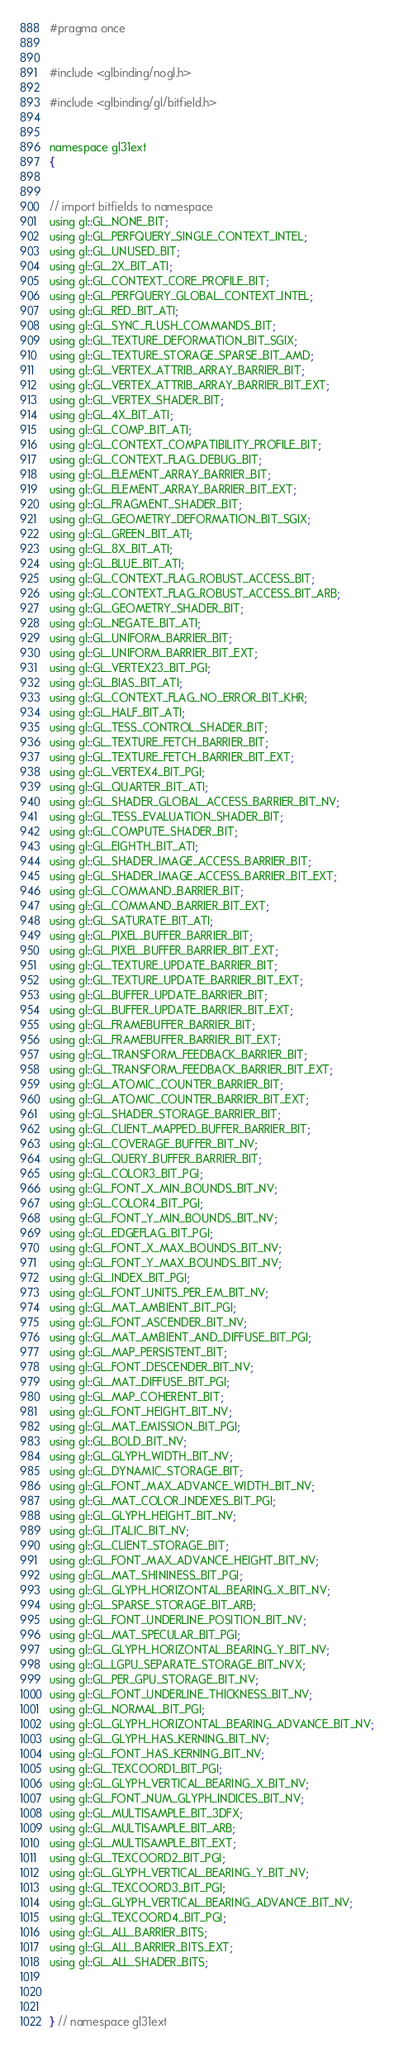<code> <loc_0><loc_0><loc_500><loc_500><_C_>
#pragma once


#include <glbinding/nogl.h>

#include <glbinding/gl/bitfield.h>


namespace gl31ext
{


// import bitfields to namespace
using gl::GL_NONE_BIT;
using gl::GL_PERFQUERY_SINGLE_CONTEXT_INTEL;
using gl::GL_UNUSED_BIT;
using gl::GL_2X_BIT_ATI;
using gl::GL_CONTEXT_CORE_PROFILE_BIT;
using gl::GL_PERFQUERY_GLOBAL_CONTEXT_INTEL;
using gl::GL_RED_BIT_ATI;
using gl::GL_SYNC_FLUSH_COMMANDS_BIT;
using gl::GL_TEXTURE_DEFORMATION_BIT_SGIX;
using gl::GL_TEXTURE_STORAGE_SPARSE_BIT_AMD;
using gl::GL_VERTEX_ATTRIB_ARRAY_BARRIER_BIT;
using gl::GL_VERTEX_ATTRIB_ARRAY_BARRIER_BIT_EXT;
using gl::GL_VERTEX_SHADER_BIT;
using gl::GL_4X_BIT_ATI;
using gl::GL_COMP_BIT_ATI;
using gl::GL_CONTEXT_COMPATIBILITY_PROFILE_BIT;
using gl::GL_CONTEXT_FLAG_DEBUG_BIT;
using gl::GL_ELEMENT_ARRAY_BARRIER_BIT;
using gl::GL_ELEMENT_ARRAY_BARRIER_BIT_EXT;
using gl::GL_FRAGMENT_SHADER_BIT;
using gl::GL_GEOMETRY_DEFORMATION_BIT_SGIX;
using gl::GL_GREEN_BIT_ATI;
using gl::GL_8X_BIT_ATI;
using gl::GL_BLUE_BIT_ATI;
using gl::GL_CONTEXT_FLAG_ROBUST_ACCESS_BIT;
using gl::GL_CONTEXT_FLAG_ROBUST_ACCESS_BIT_ARB;
using gl::GL_GEOMETRY_SHADER_BIT;
using gl::GL_NEGATE_BIT_ATI;
using gl::GL_UNIFORM_BARRIER_BIT;
using gl::GL_UNIFORM_BARRIER_BIT_EXT;
using gl::GL_VERTEX23_BIT_PGI;
using gl::GL_BIAS_BIT_ATI;
using gl::GL_CONTEXT_FLAG_NO_ERROR_BIT_KHR;
using gl::GL_HALF_BIT_ATI;
using gl::GL_TESS_CONTROL_SHADER_BIT;
using gl::GL_TEXTURE_FETCH_BARRIER_BIT;
using gl::GL_TEXTURE_FETCH_BARRIER_BIT_EXT;
using gl::GL_VERTEX4_BIT_PGI;
using gl::GL_QUARTER_BIT_ATI;
using gl::GL_SHADER_GLOBAL_ACCESS_BARRIER_BIT_NV;
using gl::GL_TESS_EVALUATION_SHADER_BIT;
using gl::GL_COMPUTE_SHADER_BIT;
using gl::GL_EIGHTH_BIT_ATI;
using gl::GL_SHADER_IMAGE_ACCESS_BARRIER_BIT;
using gl::GL_SHADER_IMAGE_ACCESS_BARRIER_BIT_EXT;
using gl::GL_COMMAND_BARRIER_BIT;
using gl::GL_COMMAND_BARRIER_BIT_EXT;
using gl::GL_SATURATE_BIT_ATI;
using gl::GL_PIXEL_BUFFER_BARRIER_BIT;
using gl::GL_PIXEL_BUFFER_BARRIER_BIT_EXT;
using gl::GL_TEXTURE_UPDATE_BARRIER_BIT;
using gl::GL_TEXTURE_UPDATE_BARRIER_BIT_EXT;
using gl::GL_BUFFER_UPDATE_BARRIER_BIT;
using gl::GL_BUFFER_UPDATE_BARRIER_BIT_EXT;
using gl::GL_FRAMEBUFFER_BARRIER_BIT;
using gl::GL_FRAMEBUFFER_BARRIER_BIT_EXT;
using gl::GL_TRANSFORM_FEEDBACK_BARRIER_BIT;
using gl::GL_TRANSFORM_FEEDBACK_BARRIER_BIT_EXT;
using gl::GL_ATOMIC_COUNTER_BARRIER_BIT;
using gl::GL_ATOMIC_COUNTER_BARRIER_BIT_EXT;
using gl::GL_SHADER_STORAGE_BARRIER_BIT;
using gl::GL_CLIENT_MAPPED_BUFFER_BARRIER_BIT;
using gl::GL_COVERAGE_BUFFER_BIT_NV;
using gl::GL_QUERY_BUFFER_BARRIER_BIT;
using gl::GL_COLOR3_BIT_PGI;
using gl::GL_FONT_X_MIN_BOUNDS_BIT_NV;
using gl::GL_COLOR4_BIT_PGI;
using gl::GL_FONT_Y_MIN_BOUNDS_BIT_NV;
using gl::GL_EDGEFLAG_BIT_PGI;
using gl::GL_FONT_X_MAX_BOUNDS_BIT_NV;
using gl::GL_FONT_Y_MAX_BOUNDS_BIT_NV;
using gl::GL_INDEX_BIT_PGI;
using gl::GL_FONT_UNITS_PER_EM_BIT_NV;
using gl::GL_MAT_AMBIENT_BIT_PGI;
using gl::GL_FONT_ASCENDER_BIT_NV;
using gl::GL_MAT_AMBIENT_AND_DIFFUSE_BIT_PGI;
using gl::GL_MAP_PERSISTENT_BIT;
using gl::GL_FONT_DESCENDER_BIT_NV;
using gl::GL_MAT_DIFFUSE_BIT_PGI;
using gl::GL_MAP_COHERENT_BIT;
using gl::GL_FONT_HEIGHT_BIT_NV;
using gl::GL_MAT_EMISSION_BIT_PGI;
using gl::GL_BOLD_BIT_NV;
using gl::GL_GLYPH_WIDTH_BIT_NV;
using gl::GL_DYNAMIC_STORAGE_BIT;
using gl::GL_FONT_MAX_ADVANCE_WIDTH_BIT_NV;
using gl::GL_MAT_COLOR_INDEXES_BIT_PGI;
using gl::GL_GLYPH_HEIGHT_BIT_NV;
using gl::GL_ITALIC_BIT_NV;
using gl::GL_CLIENT_STORAGE_BIT;
using gl::GL_FONT_MAX_ADVANCE_HEIGHT_BIT_NV;
using gl::GL_MAT_SHININESS_BIT_PGI;
using gl::GL_GLYPH_HORIZONTAL_BEARING_X_BIT_NV;
using gl::GL_SPARSE_STORAGE_BIT_ARB;
using gl::GL_FONT_UNDERLINE_POSITION_BIT_NV;
using gl::GL_MAT_SPECULAR_BIT_PGI;
using gl::GL_GLYPH_HORIZONTAL_BEARING_Y_BIT_NV;
using gl::GL_LGPU_SEPARATE_STORAGE_BIT_NVX;
using gl::GL_PER_GPU_STORAGE_BIT_NV;
using gl::GL_FONT_UNDERLINE_THICKNESS_BIT_NV;
using gl::GL_NORMAL_BIT_PGI;
using gl::GL_GLYPH_HORIZONTAL_BEARING_ADVANCE_BIT_NV;
using gl::GL_GLYPH_HAS_KERNING_BIT_NV;
using gl::GL_FONT_HAS_KERNING_BIT_NV;
using gl::GL_TEXCOORD1_BIT_PGI;
using gl::GL_GLYPH_VERTICAL_BEARING_X_BIT_NV;
using gl::GL_FONT_NUM_GLYPH_INDICES_BIT_NV;
using gl::GL_MULTISAMPLE_BIT_3DFX;
using gl::GL_MULTISAMPLE_BIT_ARB;
using gl::GL_MULTISAMPLE_BIT_EXT;
using gl::GL_TEXCOORD2_BIT_PGI;
using gl::GL_GLYPH_VERTICAL_BEARING_Y_BIT_NV;
using gl::GL_TEXCOORD3_BIT_PGI;
using gl::GL_GLYPH_VERTICAL_BEARING_ADVANCE_BIT_NV;
using gl::GL_TEXCOORD4_BIT_PGI;
using gl::GL_ALL_BARRIER_BITS;
using gl::GL_ALL_BARRIER_BITS_EXT;
using gl::GL_ALL_SHADER_BITS;



} // namespace gl31ext
</code> 